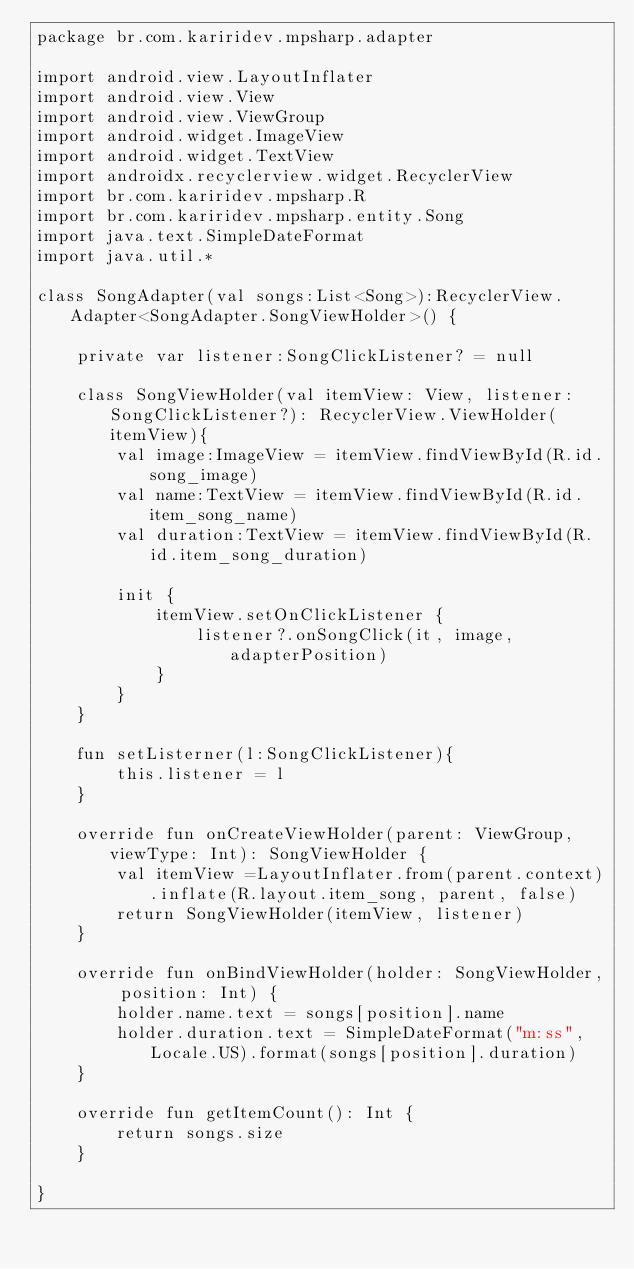Convert code to text. <code><loc_0><loc_0><loc_500><loc_500><_Kotlin_>package br.com.kariridev.mpsharp.adapter

import android.view.LayoutInflater
import android.view.View
import android.view.ViewGroup
import android.widget.ImageView
import android.widget.TextView
import androidx.recyclerview.widget.RecyclerView
import br.com.kariridev.mpsharp.R
import br.com.kariridev.mpsharp.entity.Song
import java.text.SimpleDateFormat
import java.util.*

class SongAdapter(val songs:List<Song>):RecyclerView.Adapter<SongAdapter.SongViewHolder>() {

    private var listener:SongClickListener? = null

    class SongViewHolder(val itemView: View, listener: SongClickListener?): RecyclerView.ViewHolder(itemView){
        val image:ImageView = itemView.findViewById(R.id.song_image)
        val name:TextView = itemView.findViewById(R.id.item_song_name)
        val duration:TextView = itemView.findViewById(R.id.item_song_duration)

        init {
            itemView.setOnClickListener {
                listener?.onSongClick(it, image, adapterPosition)
            }
        }
    }

    fun setListerner(l:SongClickListener){
        this.listener = l
    }

    override fun onCreateViewHolder(parent: ViewGroup, viewType: Int): SongViewHolder {
        val itemView =LayoutInflater.from(parent.context).inflate(R.layout.item_song, parent, false)
        return SongViewHolder(itemView, listener)
    }

    override fun onBindViewHolder(holder: SongViewHolder, position: Int) {
        holder.name.text = songs[position].name
        holder.duration.text = SimpleDateFormat("m:ss", Locale.US).format(songs[position].duration)
    }

    override fun getItemCount(): Int {
        return songs.size
    }

}</code> 